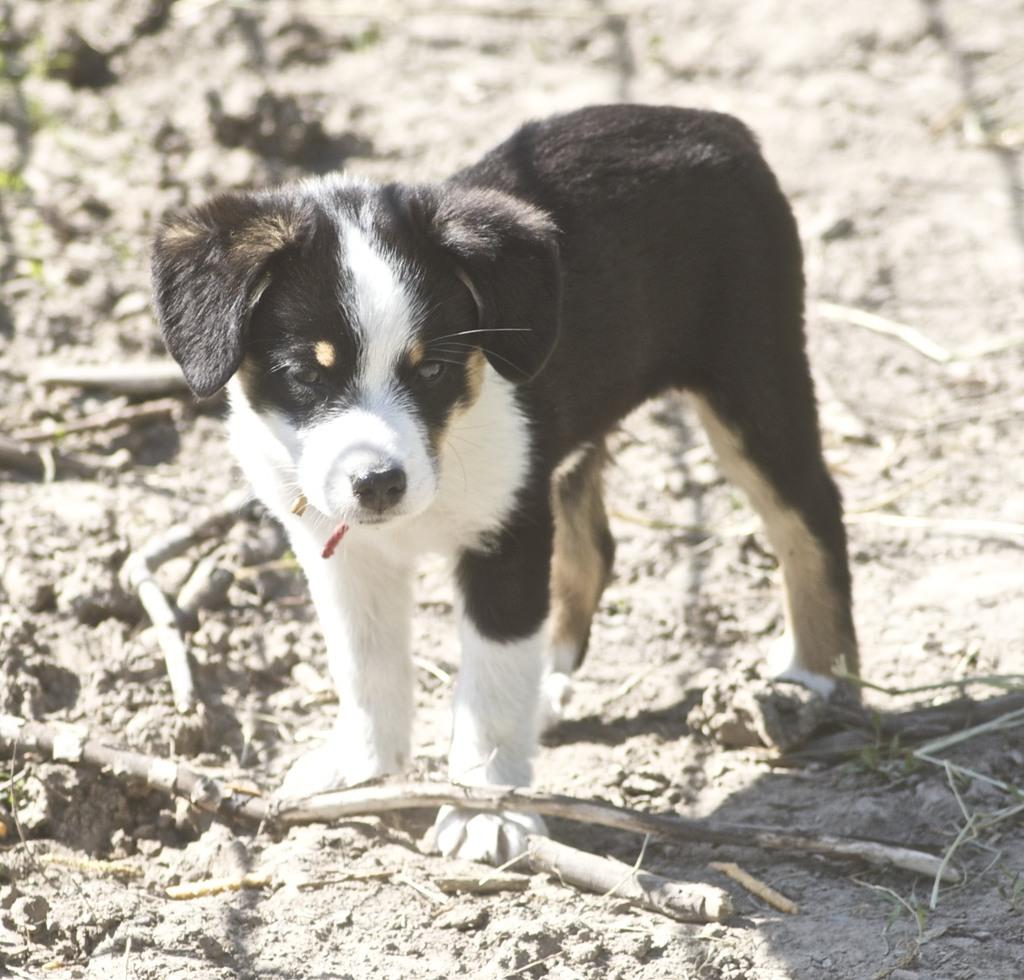What type of animal is present in the image? There is a dog in the image. What material can be seen on the ground in the image? There is wood on the ground in the image. How many giraffes can be seen in the image? There are no giraffes present in the image; it features a dog and wood on the ground. What type of hook is visible in the image? There is no hook present in the image. 